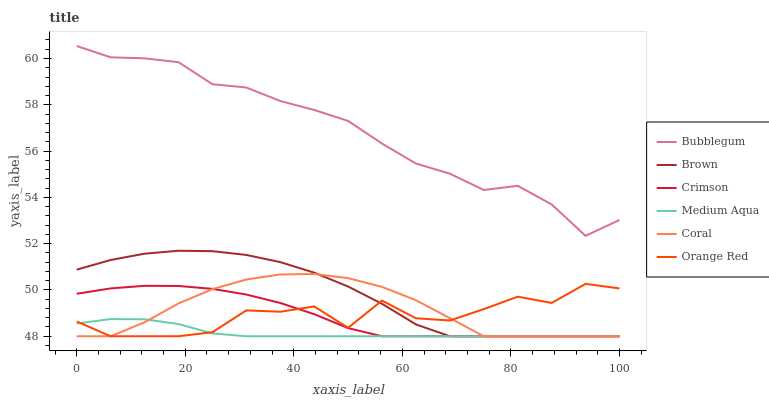Does Medium Aqua have the minimum area under the curve?
Answer yes or no. Yes. Does Bubblegum have the maximum area under the curve?
Answer yes or no. Yes. Does Coral have the minimum area under the curve?
Answer yes or no. No. Does Coral have the maximum area under the curve?
Answer yes or no. No. Is Medium Aqua the smoothest?
Answer yes or no. Yes. Is Orange Red the roughest?
Answer yes or no. Yes. Is Coral the smoothest?
Answer yes or no. No. Is Coral the roughest?
Answer yes or no. No. Does Brown have the lowest value?
Answer yes or no. Yes. Does Bubblegum have the lowest value?
Answer yes or no. No. Does Bubblegum have the highest value?
Answer yes or no. Yes. Does Coral have the highest value?
Answer yes or no. No. Is Orange Red less than Bubblegum?
Answer yes or no. Yes. Is Bubblegum greater than Medium Aqua?
Answer yes or no. Yes. Does Crimson intersect Orange Red?
Answer yes or no. Yes. Is Crimson less than Orange Red?
Answer yes or no. No. Is Crimson greater than Orange Red?
Answer yes or no. No. Does Orange Red intersect Bubblegum?
Answer yes or no. No. 